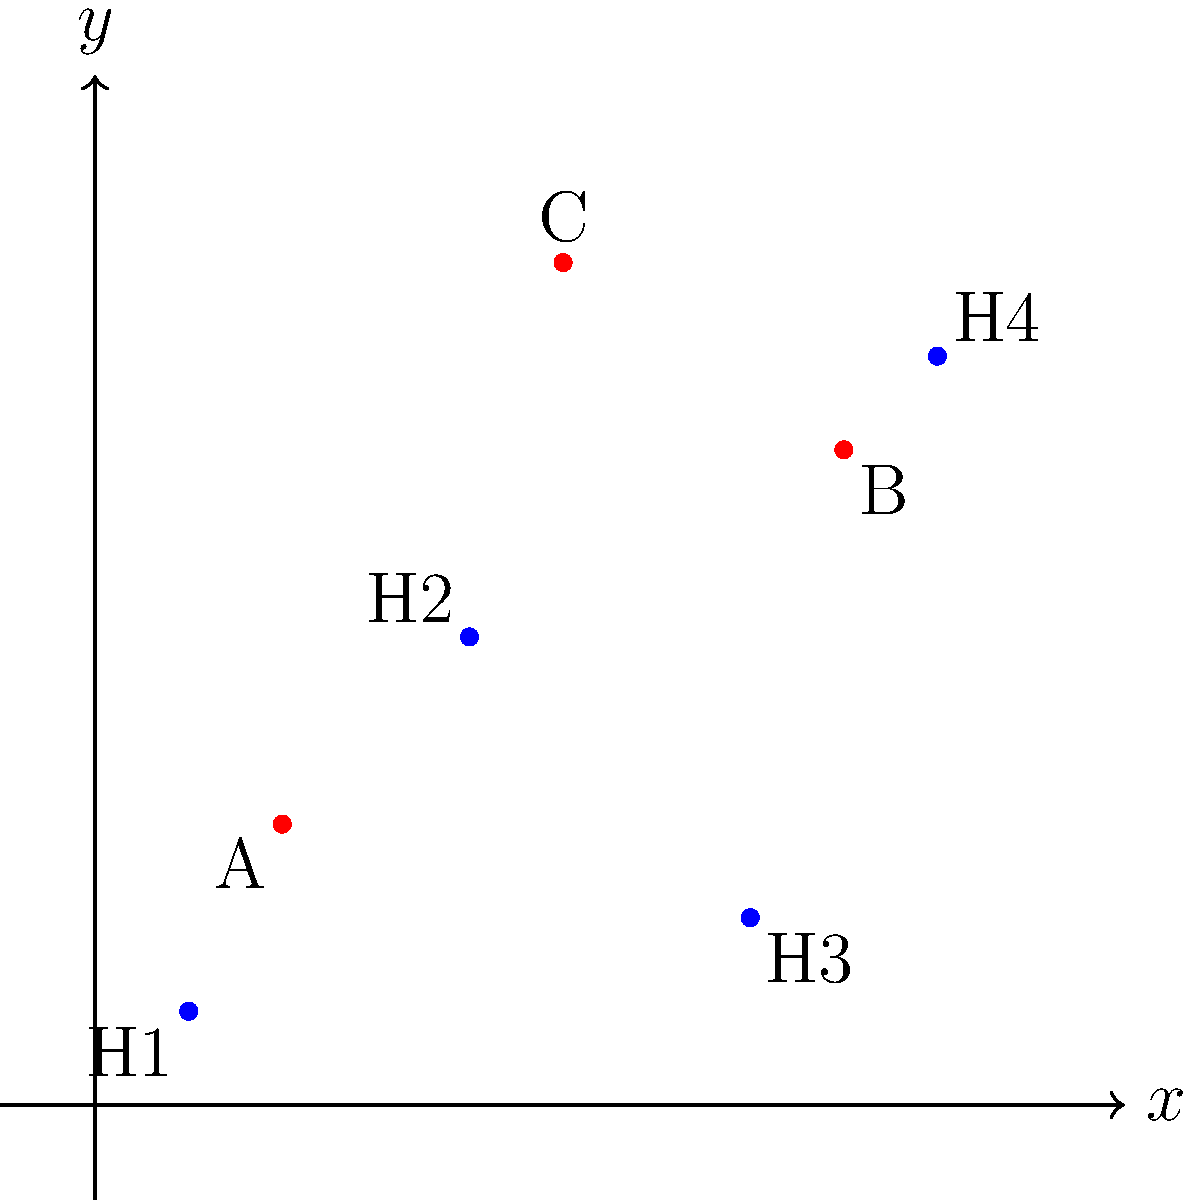In a clinical trial data management system, three data centers (A, B, and C) are located on a coordinate plane as shown: A(2,3), B(8,7), and C(5,9). Four hospitals participating in the trial are located at H1(1,1), H2(4,5), H3(7,2), and H4(9,8). To optimize data transfer efficiency and minimize potential security risks, you need to determine which data center should be assigned to each hospital based on the shortest Euclidean distance. What is the sum of the shortest distances from each hospital to its nearest data center? To solve this problem, we need to follow these steps:

1) Calculate the distance between each hospital and each data center using the Euclidean distance formula:
   $d = \sqrt{(x_2-x_1)^2 + (y_2-y_1)^2}$

2) For each hospital, determine the nearest data center.

3) Sum up the shortest distances.

Let's calculate:

For H1(1,1):
- Distance to A: $\sqrt{(2-1)^2 + (3-1)^2} = \sqrt{5} \approx 2.24$
- Distance to B: $\sqrt{(8-1)^2 + (7-1)^2} = \sqrt{85} \approx 9.22$
- Distance to C: $\sqrt{(5-1)^2 + (9-1)^2} = \sqrt{80} \approx 8.94$
Nearest is A with distance $\sqrt{5}$.

For H2(4,5):
- Distance to A: $\sqrt{(2-4)^2 + (3-5)^2} = \sqrt{8} \approx 2.83$
- Distance to B: $\sqrt{(8-4)^2 + (7-5)^2} = \sqrt{20} \approx 4.47$
- Distance to C: $\sqrt{(5-4)^2 + (9-5)^2} = \sqrt{17} \approx 4.12$
Nearest is A with distance $\sqrt{8}$.

For H3(7,2):
- Distance to A: $\sqrt{(2-7)^2 + (3-2)^2} = \sqrt{26} \approx 5.10$
- Distance to B: $\sqrt{(8-7)^2 + (7-2)^2} = \sqrt{26} \approx 5.10$
- Distance to C: $\sqrt{(5-7)^2 + (9-2)^2} = \sqrt{53} \approx 7.28$
Nearest is B with distance $\sqrt{26}$.

For H4(9,8):
- Distance to A: $\sqrt{(2-9)^2 + (3-8)^2} = \sqrt{106} \approx 10.30$
- Distance to B: $\sqrt{(8-9)^2 + (7-8)^2} = \sqrt{2} \approx 1.41$
- Distance to C: $\sqrt{(5-9)^2 + (9-8)^2} = \sqrt{17} \approx 4.12$
Nearest is B with distance $\sqrt{2}$.

The sum of the shortest distances is:
$\sqrt{5} + \sqrt{8} + \sqrt{26} + \sqrt{2}$
Answer: $\sqrt{5} + \sqrt{8} + \sqrt{26} + \sqrt{2}$ 